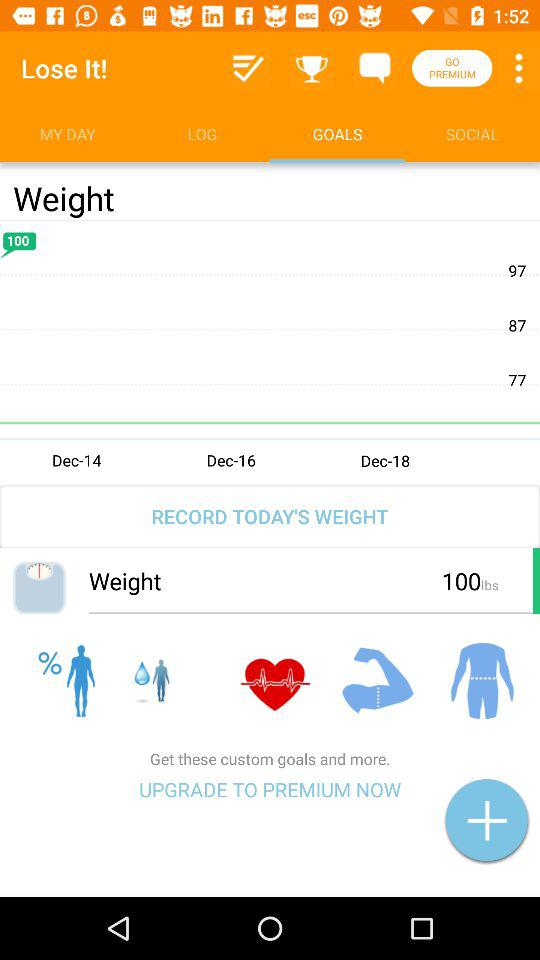How many pounds does the user want to lose?
Answer the question using a single word or phrase. 100 